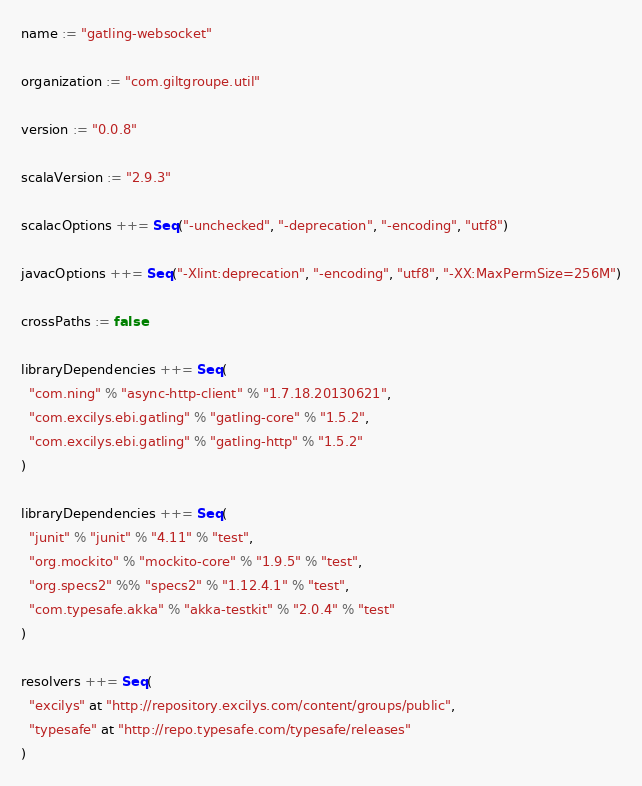<code> <loc_0><loc_0><loc_500><loc_500><_Scala_>name := "gatling-websocket"

organization := "com.giltgroupe.util"

version := "0.0.8"

scalaVersion := "2.9.3"

scalacOptions ++= Seq("-unchecked", "-deprecation", "-encoding", "utf8")

javacOptions ++= Seq("-Xlint:deprecation", "-encoding", "utf8", "-XX:MaxPermSize=256M")

crossPaths := false

libraryDependencies ++= Seq(
  "com.ning" % "async-http-client" % "1.7.18.20130621",
  "com.excilys.ebi.gatling" % "gatling-core" % "1.5.2",
  "com.excilys.ebi.gatling" % "gatling-http" % "1.5.2"
)

libraryDependencies ++= Seq(
  "junit" % "junit" % "4.11" % "test",
  "org.mockito" % "mockito-core" % "1.9.5" % "test",
  "org.specs2" %% "specs2" % "1.12.4.1" % "test",
  "com.typesafe.akka" % "akka-testkit" % "2.0.4" % "test"
)

resolvers ++= Seq(
  "excilys" at "http://repository.excilys.com/content/groups/public",
  "typesafe" at "http://repo.typesafe.com/typesafe/releases"
)
</code> 